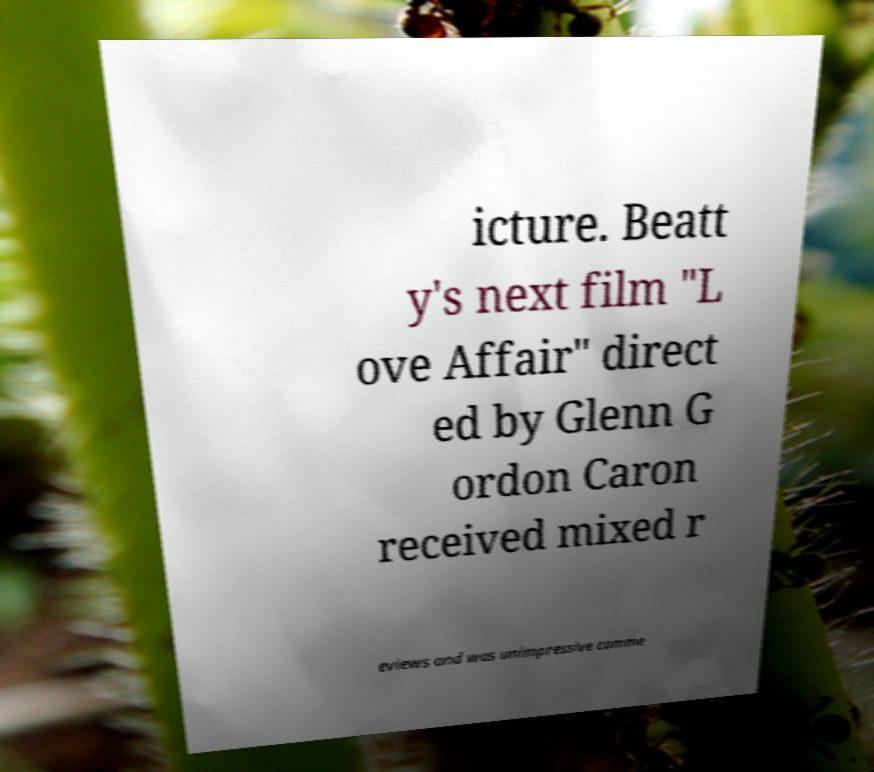Could you extract and type out the text from this image? icture. Beatt y's next film "L ove Affair" direct ed by Glenn G ordon Caron received mixed r eviews and was unimpressive comme 